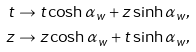Convert formula to latex. <formula><loc_0><loc_0><loc_500><loc_500>t \to t \cosh \alpha _ { w } + z \sinh \alpha _ { w } , \\ z \to z \cosh \alpha _ { w } + t \sinh \alpha _ { w } ,</formula> 